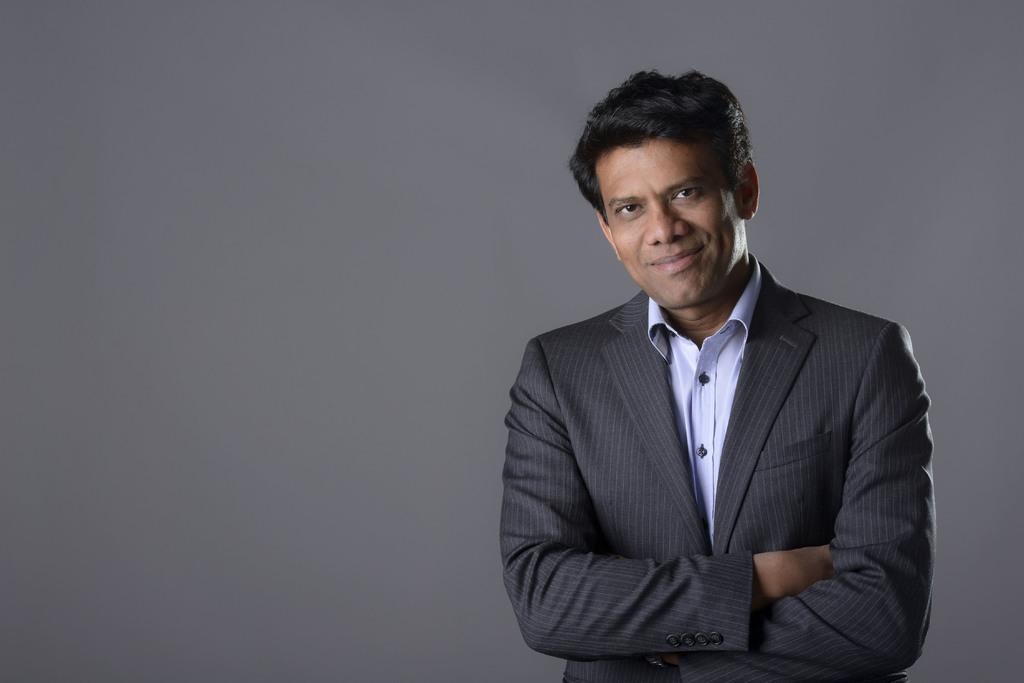What is the main subject of the picture? The main subject of the picture is a man. What is the man doing in the picture? The man is standing in the picture. What is the man's facial expression in the picture? The man is smiling in the picture. What can be seen in the background of the image? The background of the image is plain. What type of clothing is the man wearing in the picture? The man is wearing a coat in the picture. What type of train can be seen in the image? There is no train present in the image. 